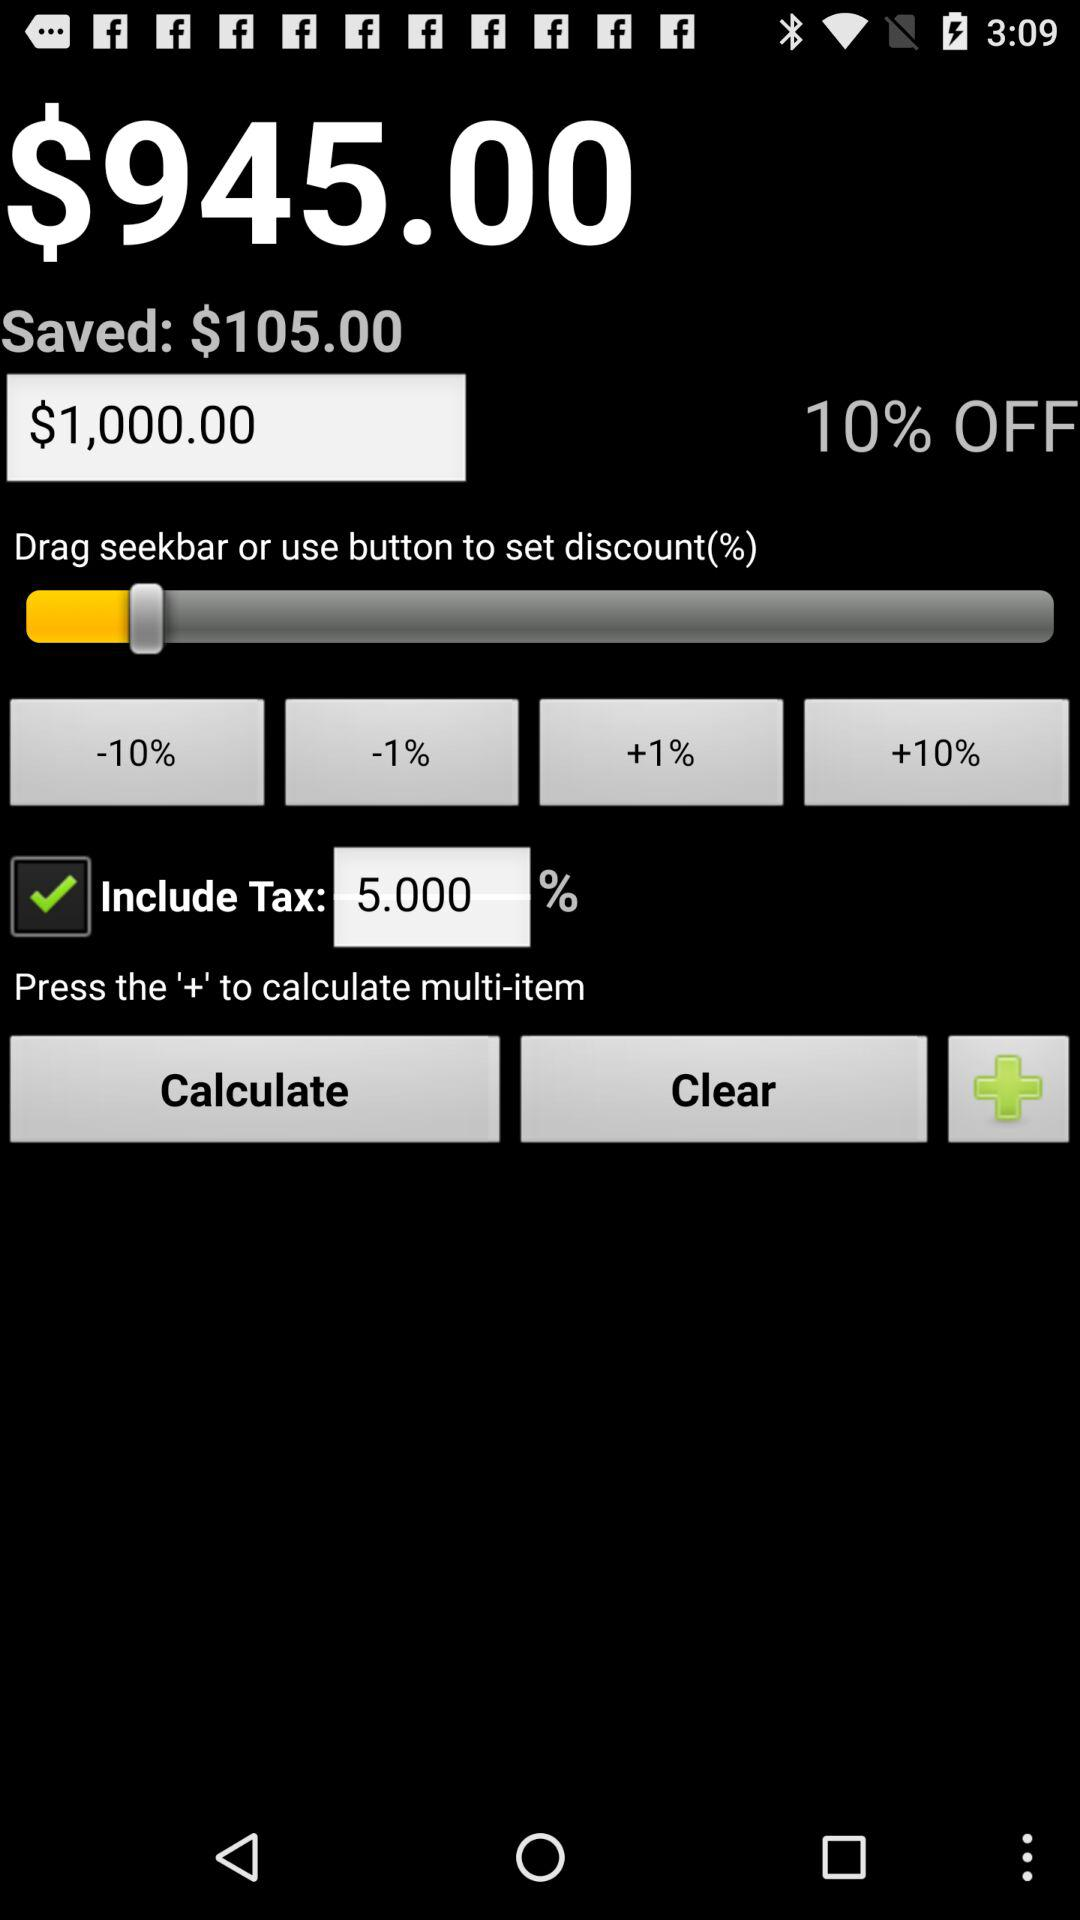How much is the discount? The discount is 10%. 